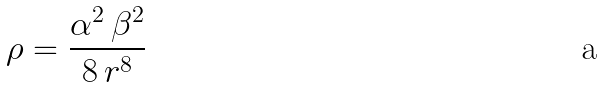<formula> <loc_0><loc_0><loc_500><loc_500>\rho = \frac { \alpha ^ { 2 } \, \beta ^ { 2 } } { 8 \, r ^ { 8 } }</formula> 